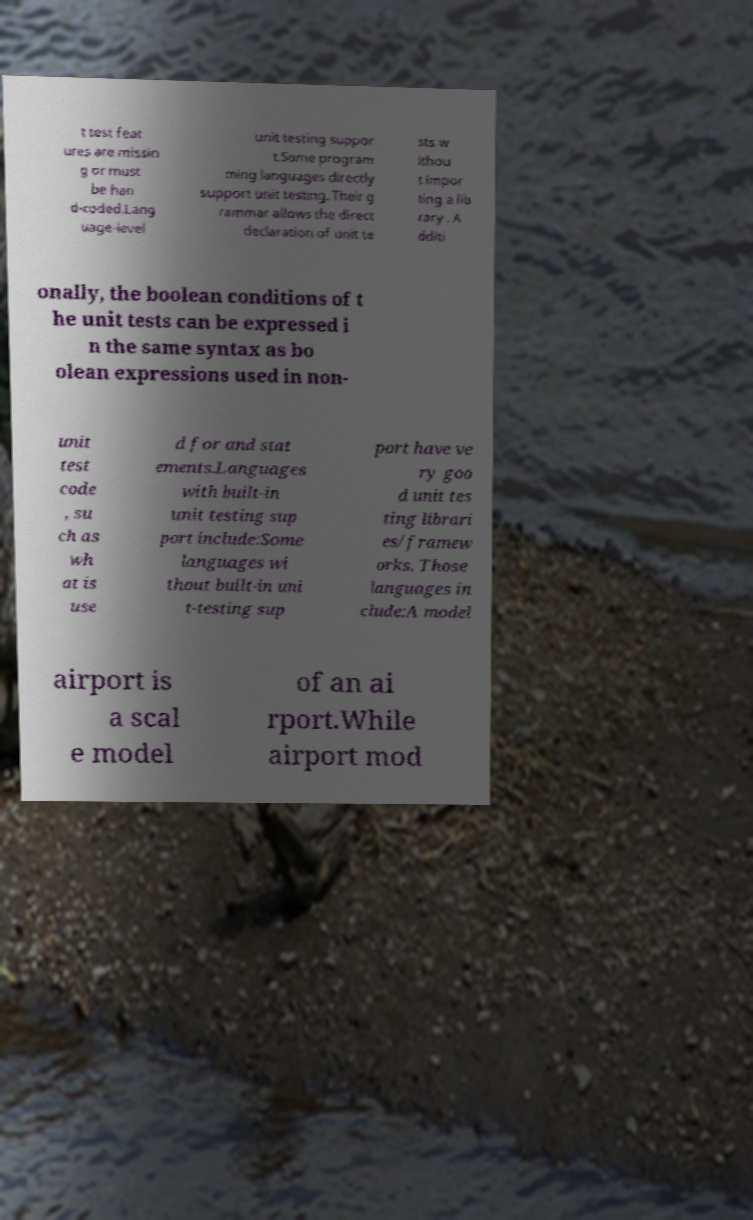Could you assist in decoding the text presented in this image and type it out clearly? t test feat ures are missin g or must be han d-coded.Lang uage-level unit testing suppor t.Some program ming languages directly support unit testing. Their g rammar allows the direct declaration of unit te sts w ithou t impor ting a lib rary . A dditi onally, the boolean conditions of t he unit tests can be expressed i n the same syntax as bo olean expressions used in non- unit test code , su ch as wh at is use d for and stat ements.Languages with built-in unit testing sup port include:Some languages wi thout built-in uni t-testing sup port have ve ry goo d unit tes ting librari es/framew orks. Those languages in clude:A model airport is a scal e model of an ai rport.While airport mod 